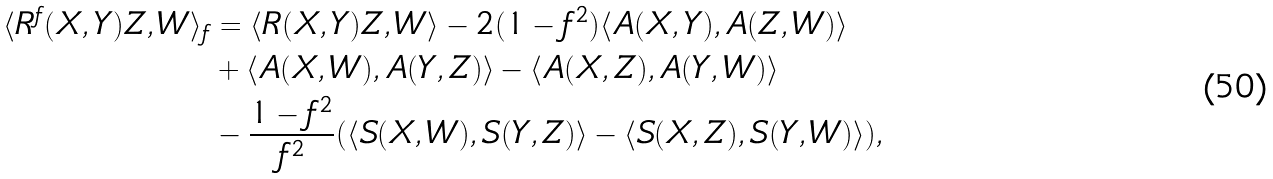<formula> <loc_0><loc_0><loc_500><loc_500>\langle R ^ { f } ( X , Y ) Z , W \rangle _ { f } & = \langle R ( X , Y ) Z , W \rangle - 2 ( 1 - f ^ { 2 } ) \langle A ( X , Y ) , A ( Z , W ) \rangle \\ & + \langle A ( X , W ) , A ( Y , Z ) \rangle - \langle A ( X , Z ) , A ( Y , W ) \rangle \\ & - \frac { 1 - f ^ { 2 } } { f ^ { 2 } } ( \langle S ( X , W ) , S ( Y , Z ) \rangle - \langle S ( X , Z ) , S ( Y , W ) \rangle ) ,</formula> 